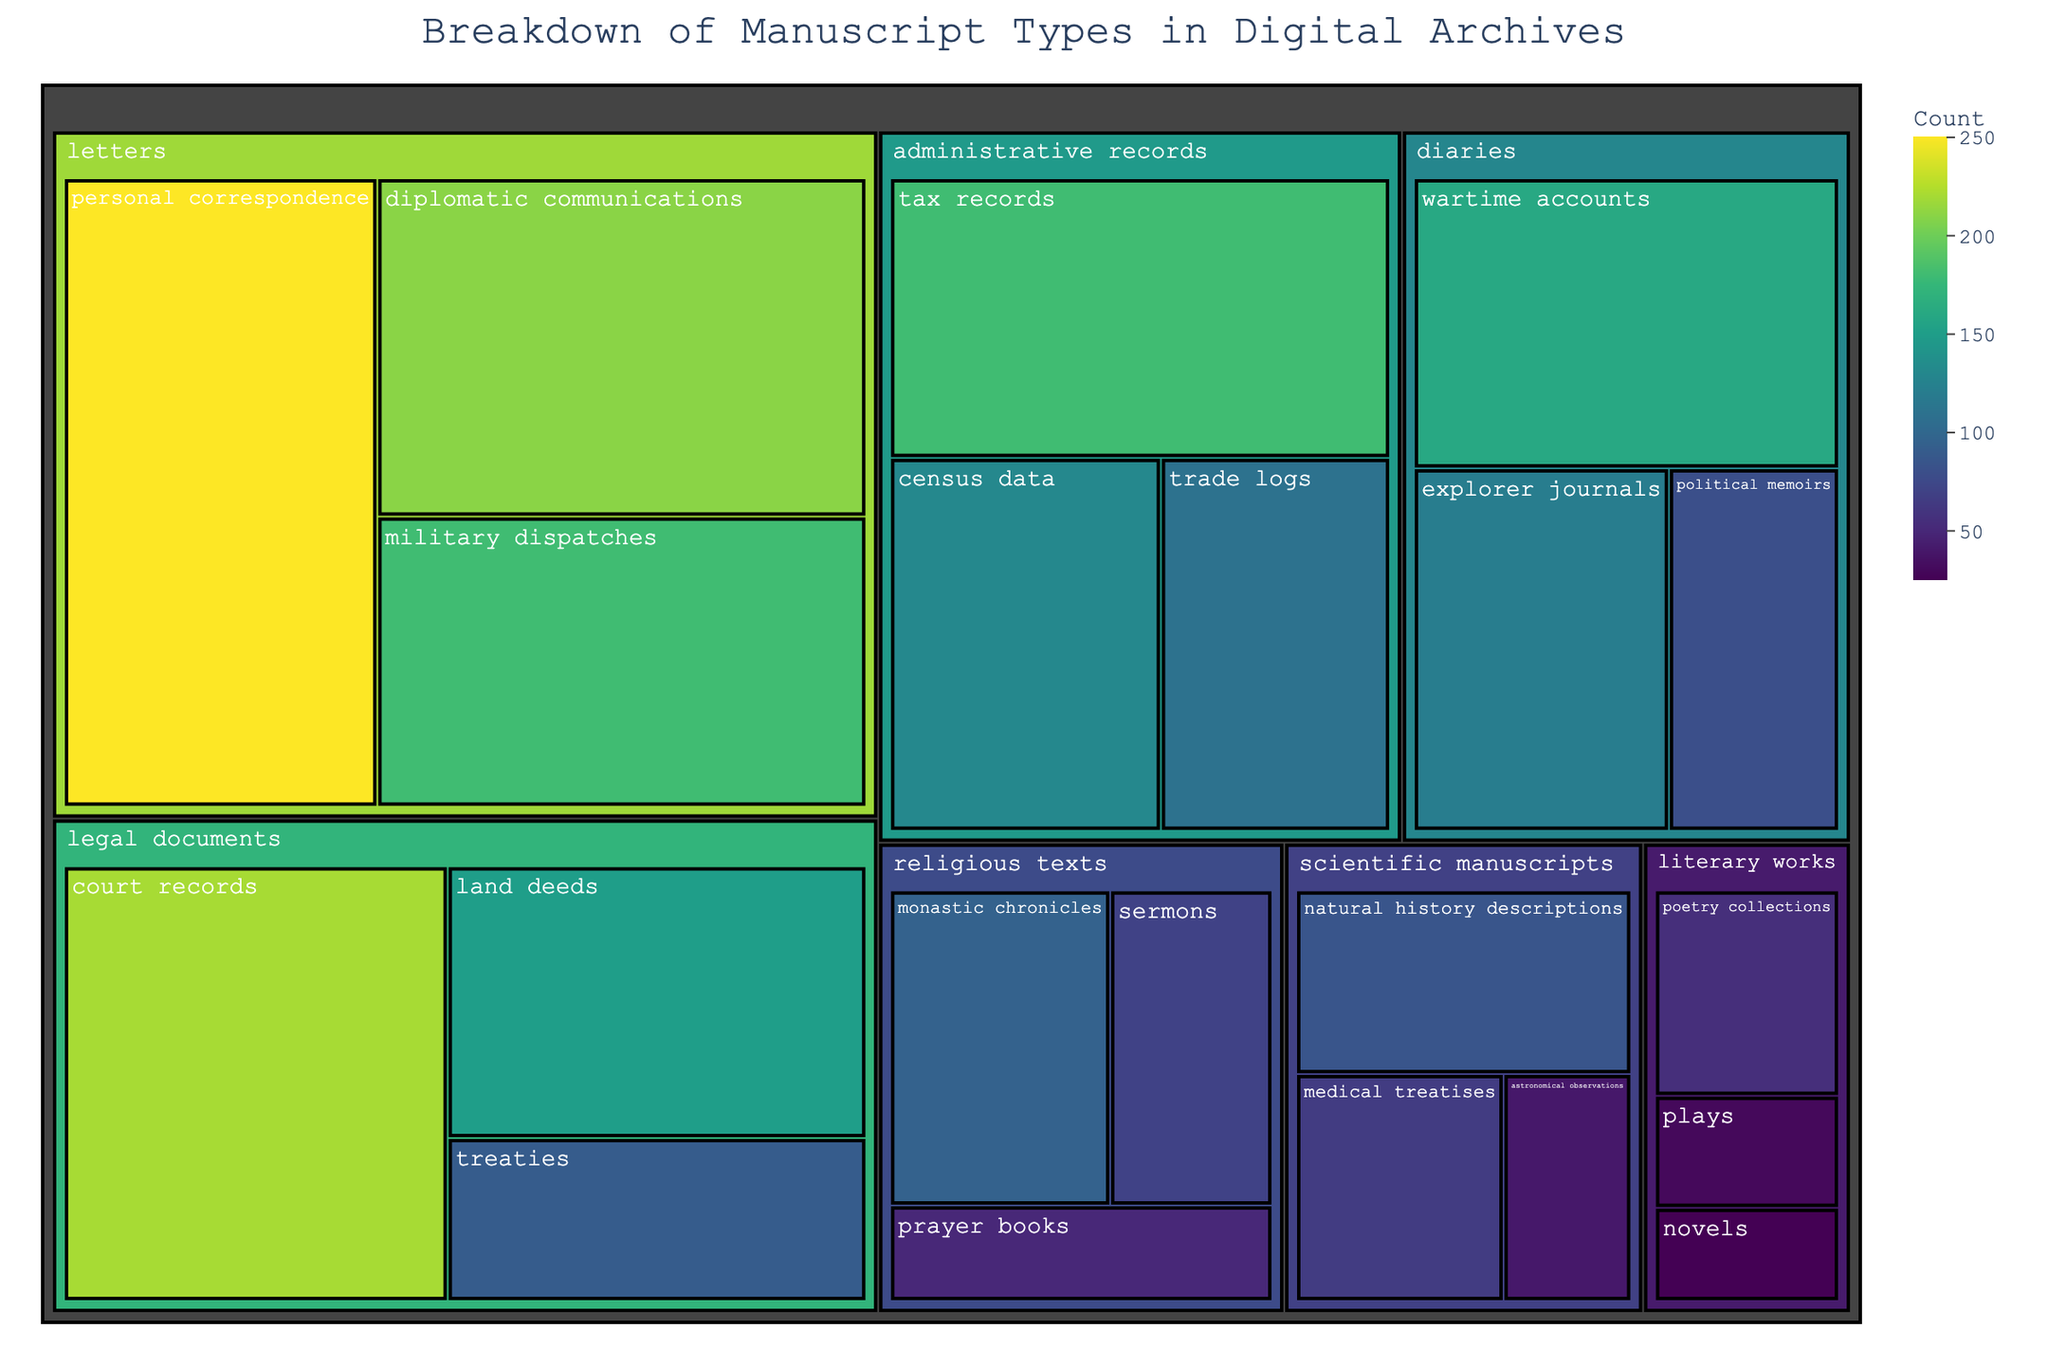what is the title of the treemap? The title is clearly displayed at the top of the treemap and reads: "Breakdown of Manuscript Types in Digital Archives"
Answer: Breakdown of Manuscript Types in Digital Archives Which format has the highest count of manuscripts? By scanning the treemap, the "letters" format appears to have the largest sections based on color intensity and area size, indicating the highest count in total.
Answer: letters What is the total count for scientific manuscripts? Add the counts of all subcategories under scientific manuscripts: 40 (astronomical observations) + 65 (medical treatises) + 85 (natural history descriptions) = 190.
Answer: 190 Which subject within legal documents has the smallest count? Looking at the color intensity and area size within legal documents, "treaties" is the smallest, having a count of 90.
Answer: treaties Compare military dispatches and political memoirs. Which has a higher count and by how much? The count for military dispatches is 180, and for political memoirs, it is 80. Subtracting the smaller count from the larger gives 180 - 80 = 100.
Answer: military dispatches by 100 What is the combined count of all diaries? Add the counts for all diary subcategories: 120 (explorer journals) + 80 (political memoirs) + 160 (wartime accounts) = 360.
Answer: 360 Which subject within administrative records has the highest count? By reviewing the subcategories under administrative records, "tax records" has the highest count at 180.
Answer: tax records How does the count of trade logs compare to court records? Trade logs have a count of 110, whereas court records have a count of 220. Comparing these, court records are larger by 220 - 110 = 110.
Answer: court records by 110 Which format has the widest variety of subjects? "Letters" have the most subcategories (personal correspondence, military dispatches, diplomatic communications), making it the format with the widest variety.
Answer: letters What is the overall count of all literary works combined? Sum the counts of subcategories under literary works: 55 (poetry collections) + 30 (plays) + 25 (novels) = 110.
Answer: 110 